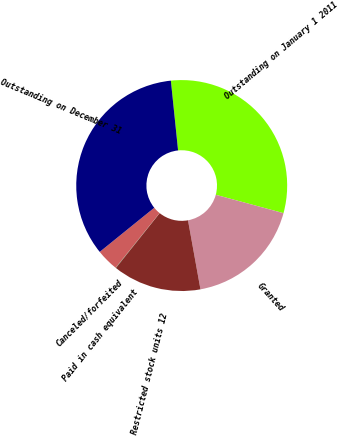<chart> <loc_0><loc_0><loc_500><loc_500><pie_chart><fcel>Outstanding on January 1 2011<fcel>Granted<fcel>Restricted stock units 12<fcel>Paid in cash equivalent<fcel>Canceled/forfeited<fcel>Outstanding on December 31<nl><fcel>30.86%<fcel>17.94%<fcel>13.57%<fcel>0.06%<fcel>3.39%<fcel>34.19%<nl></chart> 